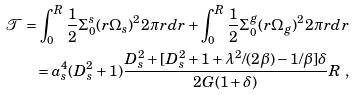<formula> <loc_0><loc_0><loc_500><loc_500>\mathcal { T } = \int _ { 0 } ^ { R } \frac { 1 } { 2 } \Sigma _ { 0 } ^ { s } ( r \Omega _ { s } ) ^ { 2 } 2 \pi r d r + \int _ { 0 } ^ { R } \frac { 1 } { 2 } \Sigma _ { 0 } ^ { g } ( r \Omega _ { g } ) ^ { 2 } 2 \pi r d r \\ = a _ { s } ^ { 4 } ( D _ { s } ^ { 2 } + 1 ) \frac { D _ { s } ^ { 2 } + [ D _ { s } ^ { 2 } + 1 + \lambda ^ { 2 } / ( 2 \beta ) - 1 / \beta ] \delta } { 2 G ( 1 + \delta ) } R \ ,</formula> 